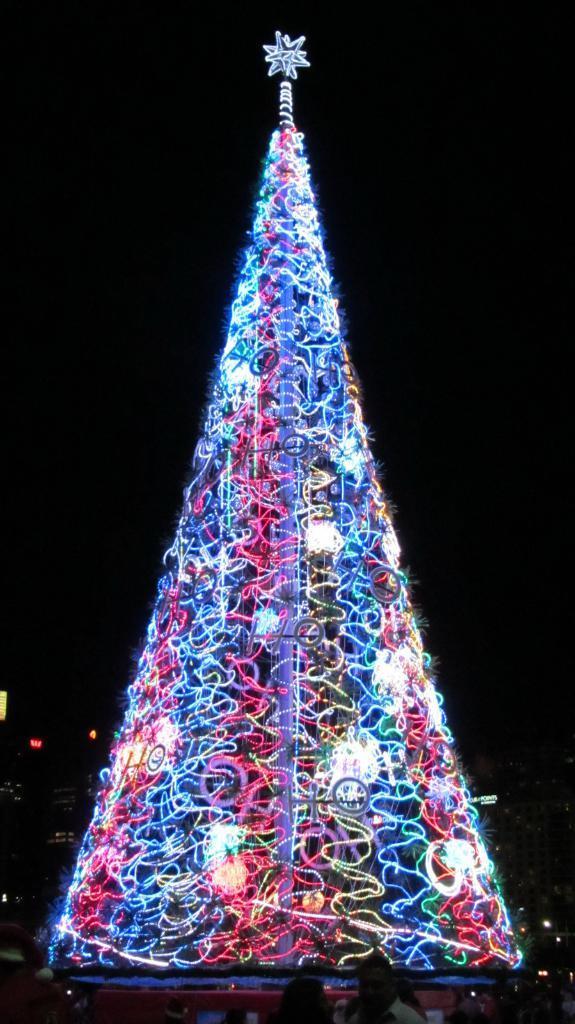Can you describe this image briefly? In this picture we can see some people at the bottom, it looks like a Christmas tree in the middle, we can see lights on the tree, there are two lights in the background, we can see a dark background. 